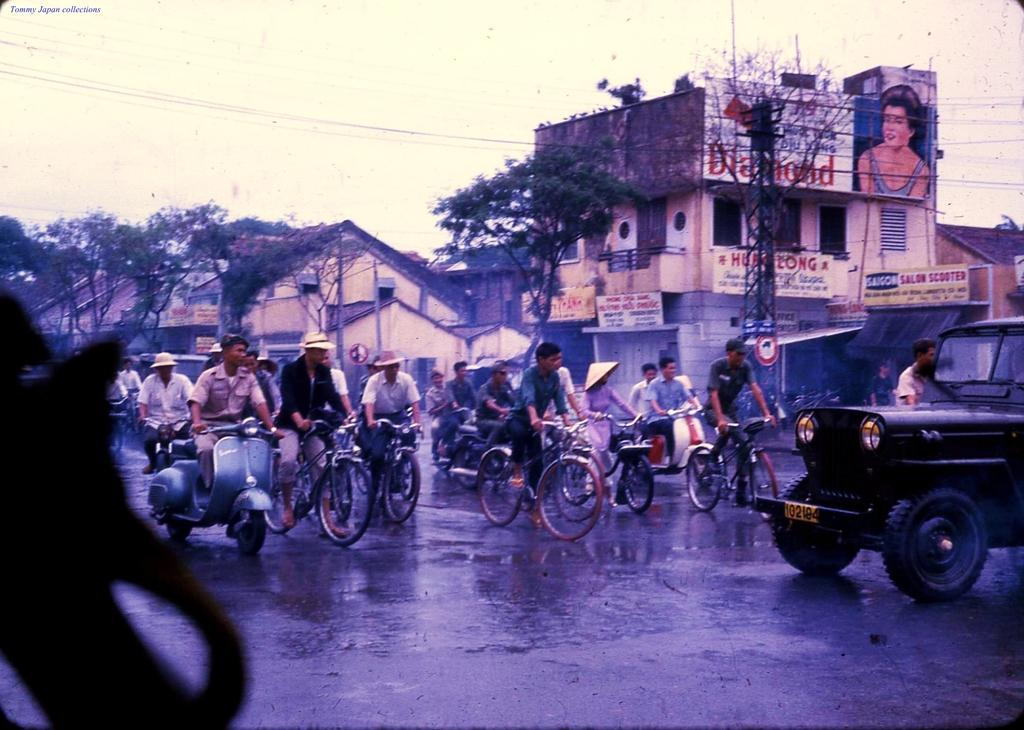What are the people in the image doing? The people in the image are riding vehicles on the road. What can be seen in the background of the image? There are buildings, trees, a pole, a sign board, hoardings, and the sky visible in the background. How many vehicles can be seen in the image? The number of vehicles is not specified, but there are people riding vehicles on the road. What type of love can be seen between the elbow and the pole in the image? There is no love or elbow present in the image; it features people riding vehicles on the road with a pole and other background elements. 